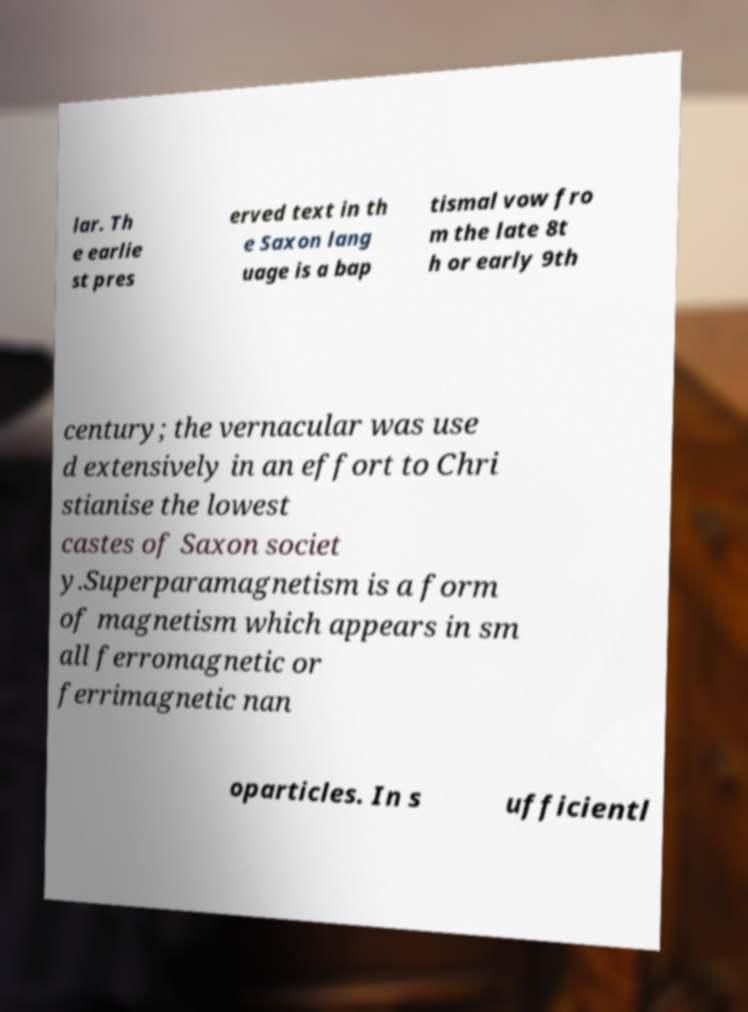Can you read and provide the text displayed in the image?This photo seems to have some interesting text. Can you extract and type it out for me? lar. Th e earlie st pres erved text in th e Saxon lang uage is a bap tismal vow fro m the late 8t h or early 9th century; the vernacular was use d extensively in an effort to Chri stianise the lowest castes of Saxon societ y.Superparamagnetism is a form of magnetism which appears in sm all ferromagnetic or ferrimagnetic nan oparticles. In s ufficientl 